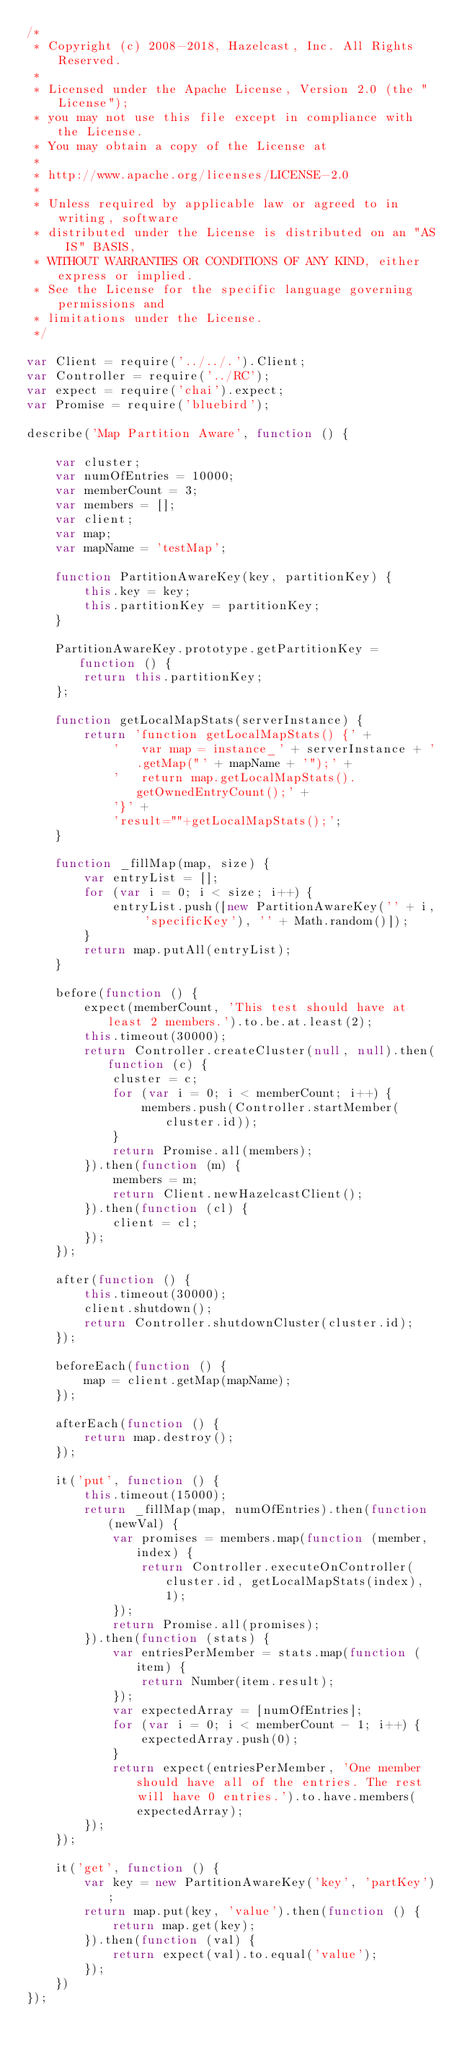Convert code to text. <code><loc_0><loc_0><loc_500><loc_500><_JavaScript_>/*
 * Copyright (c) 2008-2018, Hazelcast, Inc. All Rights Reserved.
 *
 * Licensed under the Apache License, Version 2.0 (the "License");
 * you may not use this file except in compliance with the License.
 * You may obtain a copy of the License at
 *
 * http://www.apache.org/licenses/LICENSE-2.0
 *
 * Unless required by applicable law or agreed to in writing, software
 * distributed under the License is distributed on an "AS IS" BASIS,
 * WITHOUT WARRANTIES OR CONDITIONS OF ANY KIND, either express or implied.
 * See the License for the specific language governing permissions and
 * limitations under the License.
 */

var Client = require('../../.').Client;
var Controller = require('../RC');
var expect = require('chai').expect;
var Promise = require('bluebird');

describe('Map Partition Aware', function () {

    var cluster;
    var numOfEntries = 10000;
    var memberCount = 3;
    var members = [];
    var client;
    var map;
    var mapName = 'testMap';

    function PartitionAwareKey(key, partitionKey) {
        this.key = key;
        this.partitionKey = partitionKey;
    }

    PartitionAwareKey.prototype.getPartitionKey = function () {
        return this.partitionKey;
    };

    function getLocalMapStats(serverInstance) {
        return 'function getLocalMapStats() {' +
            '   var map = instance_' + serverInstance + '.getMap("' + mapName + '");' +
            '   return map.getLocalMapStats().getOwnedEntryCount();' +
            '}' +
            'result=""+getLocalMapStats();';
    }

    function _fillMap(map, size) {
        var entryList = [];
        for (var i = 0; i < size; i++) {
            entryList.push([new PartitionAwareKey('' + i, 'specificKey'), '' + Math.random()]);
        }
        return map.putAll(entryList);
    }

    before(function () {
        expect(memberCount, 'This test should have at least 2 members.').to.be.at.least(2);
        this.timeout(30000);
        return Controller.createCluster(null, null).then(function (c) {
            cluster = c;
            for (var i = 0; i < memberCount; i++) {
                members.push(Controller.startMember(cluster.id));
            }
            return Promise.all(members);
        }).then(function (m) {
            members = m;
            return Client.newHazelcastClient();
        }).then(function (cl) {
            client = cl;
        });
    });

    after(function () {
        this.timeout(30000);
        client.shutdown();
        return Controller.shutdownCluster(cluster.id);
    });

    beforeEach(function () {
        map = client.getMap(mapName);
    });

    afterEach(function () {
        return map.destroy();
    });

    it('put', function () {
        this.timeout(15000);
        return _fillMap(map, numOfEntries).then(function (newVal) {
            var promises = members.map(function (member, index) {
                return Controller.executeOnController(cluster.id, getLocalMapStats(index), 1);
            });
            return Promise.all(promises);
        }).then(function (stats) {
            var entriesPerMember = stats.map(function (item) {
                return Number(item.result);
            });
            var expectedArray = [numOfEntries];
            for (var i = 0; i < memberCount - 1; i++) {
                expectedArray.push(0);
            }
            return expect(entriesPerMember, 'One member should have all of the entries. The rest will have 0 entries.').to.have.members(expectedArray);
        });
    });

    it('get', function () {
        var key = new PartitionAwareKey('key', 'partKey');
        return map.put(key, 'value').then(function () {
            return map.get(key);
        }).then(function (val) {
            return expect(val).to.equal('value');
        });
    })
});
</code> 